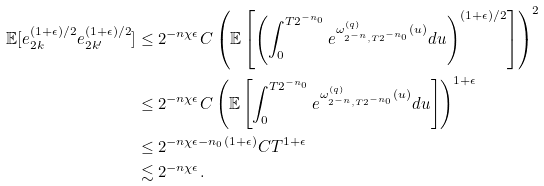Convert formula to latex. <formula><loc_0><loc_0><loc_500><loc_500>\mathbb { E } [ e _ { 2 k } ^ { ( 1 + \epsilon ) / 2 } e _ { 2 k ^ { \prime } } ^ { ( 1 + \epsilon ) / 2 } ] & \leq 2 ^ { - n \chi \epsilon } C \left ( \mathbb { E } \left [ \left ( \int _ { 0 } ^ { T 2 ^ { - n _ { 0 } } } e ^ { \omega _ { 2 ^ { - n } , T 2 ^ { - n _ { 0 } } } ^ { ( q ) } ( u ) } d u \right ) ^ { ( 1 + \epsilon ) / 2 } \right ] \right ) ^ { 2 } \\ & \leq 2 ^ { - n \chi \epsilon } C \left ( \mathbb { E } \left [ \int _ { 0 } ^ { T 2 ^ { - n _ { 0 } } } e ^ { \omega _ { 2 ^ { - n } , T 2 ^ { - n _ { 0 } } } ^ { ( q ) } ( u ) } d u \right ] \right ) ^ { 1 + \epsilon } \\ & \leq 2 ^ { - n \chi \epsilon - n _ { 0 } ( 1 + \epsilon ) } C T ^ { 1 + \epsilon } \\ & \lesssim 2 ^ { - n \chi \epsilon } .</formula> 